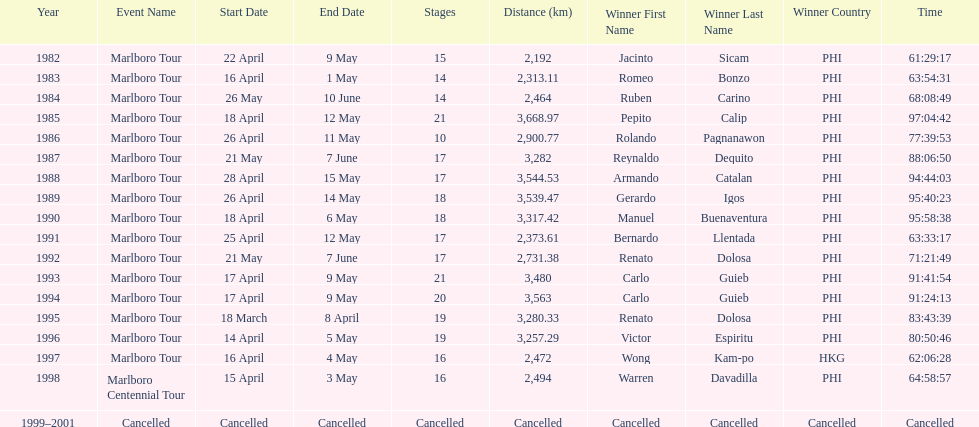Who is listed before wong kam-po? Victor Espiritu (PHI). 